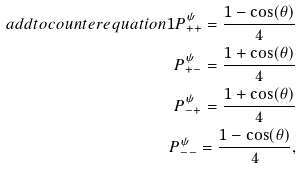Convert formula to latex. <formula><loc_0><loc_0><loc_500><loc_500>\ a d d t o c o u n t e r { e q u a t i o n } { 1 } P _ { + + } ^ { \psi } = \frac { 1 - \cos ( \theta ) } 4 \\ P _ { + - } ^ { \psi } = \frac { 1 + \cos ( \theta ) } 4 \\ P _ { - + } ^ { \psi } = \frac { 1 + \cos ( \theta ) } 4 \\ P _ { - - } ^ { \psi } = \frac { 1 - \cos ( \theta ) } 4 ,</formula> 